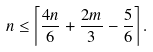<formula> <loc_0><loc_0><loc_500><loc_500>n \leq \left \lceil \frac { 4 n } { 6 } + \frac { 2 m } { 3 } - \frac { 5 } { 6 } \right \rceil .</formula> 